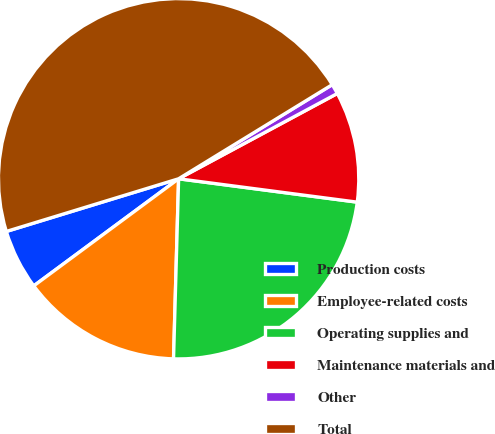<chart> <loc_0><loc_0><loc_500><loc_500><pie_chart><fcel>Production costs<fcel>Employee-related costs<fcel>Operating supplies and<fcel>Maintenance materials and<fcel>Other<fcel>Total<nl><fcel>5.41%<fcel>14.42%<fcel>23.38%<fcel>9.92%<fcel>0.9%<fcel>45.98%<nl></chart> 